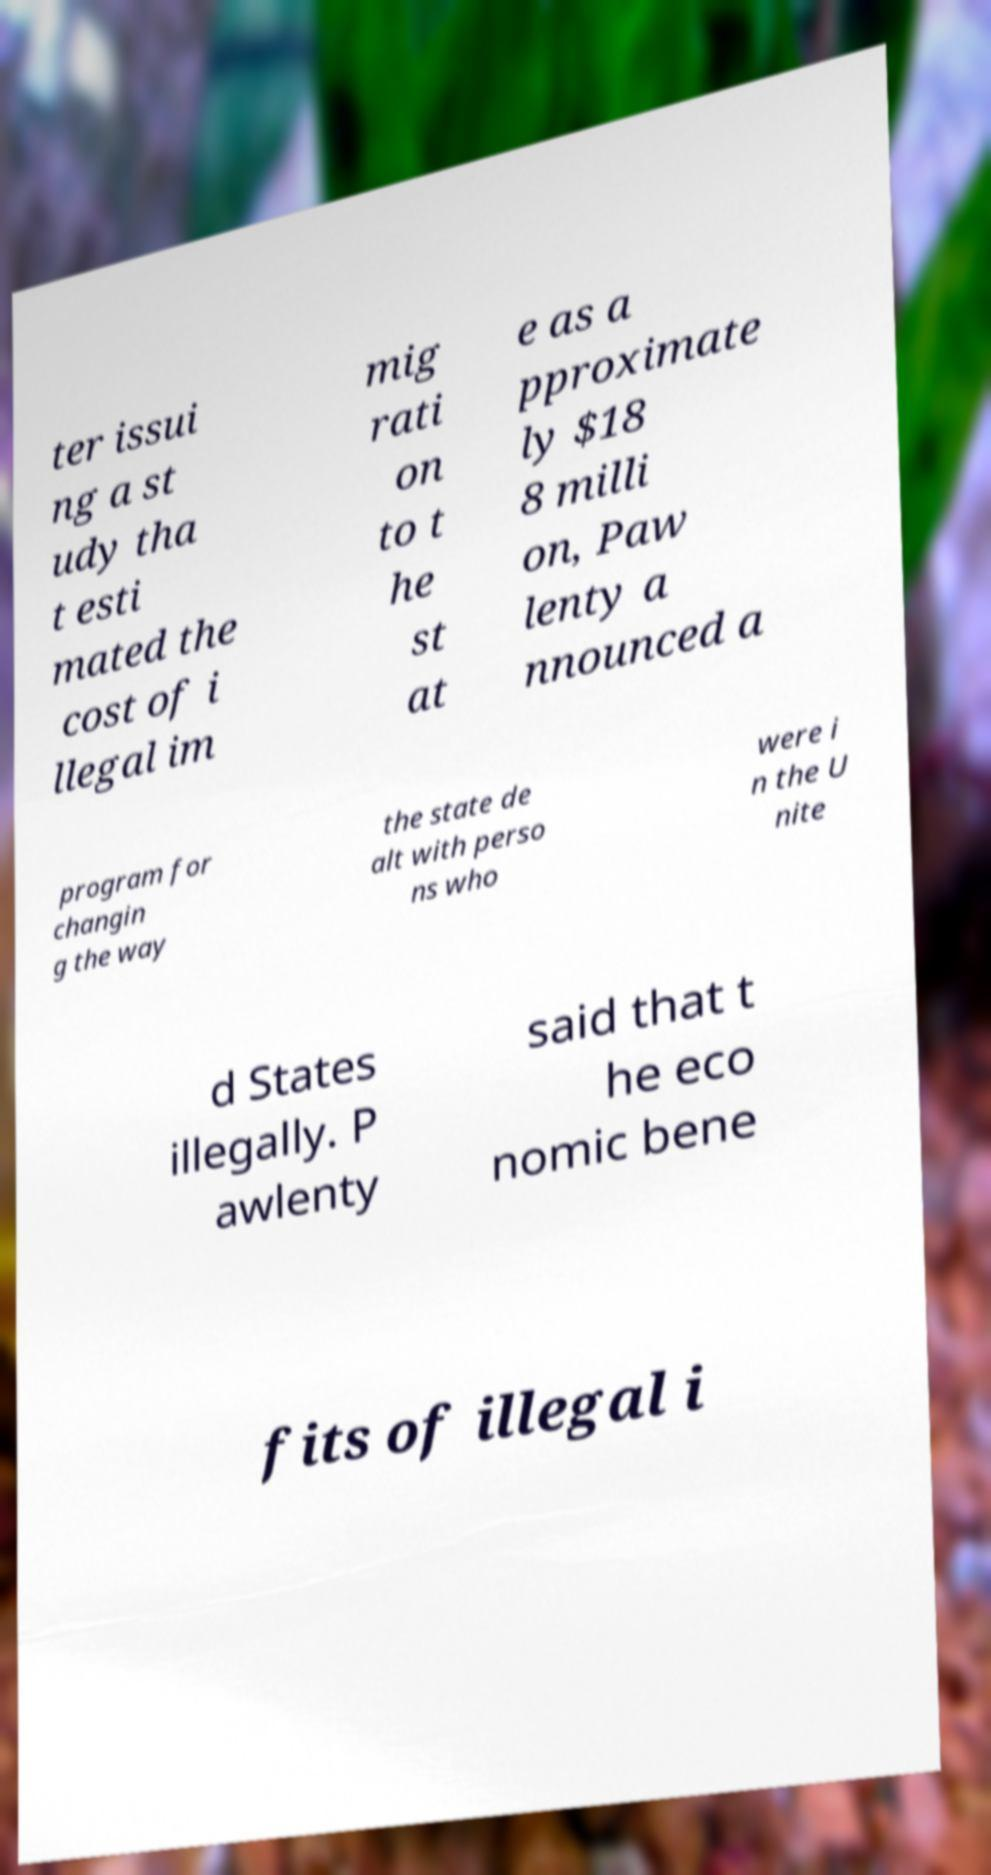For documentation purposes, I need the text within this image transcribed. Could you provide that? ter issui ng a st udy tha t esti mated the cost of i llegal im mig rati on to t he st at e as a pproximate ly $18 8 milli on, Paw lenty a nnounced a program for changin g the way the state de alt with perso ns who were i n the U nite d States illegally. P awlenty said that t he eco nomic bene fits of illegal i 